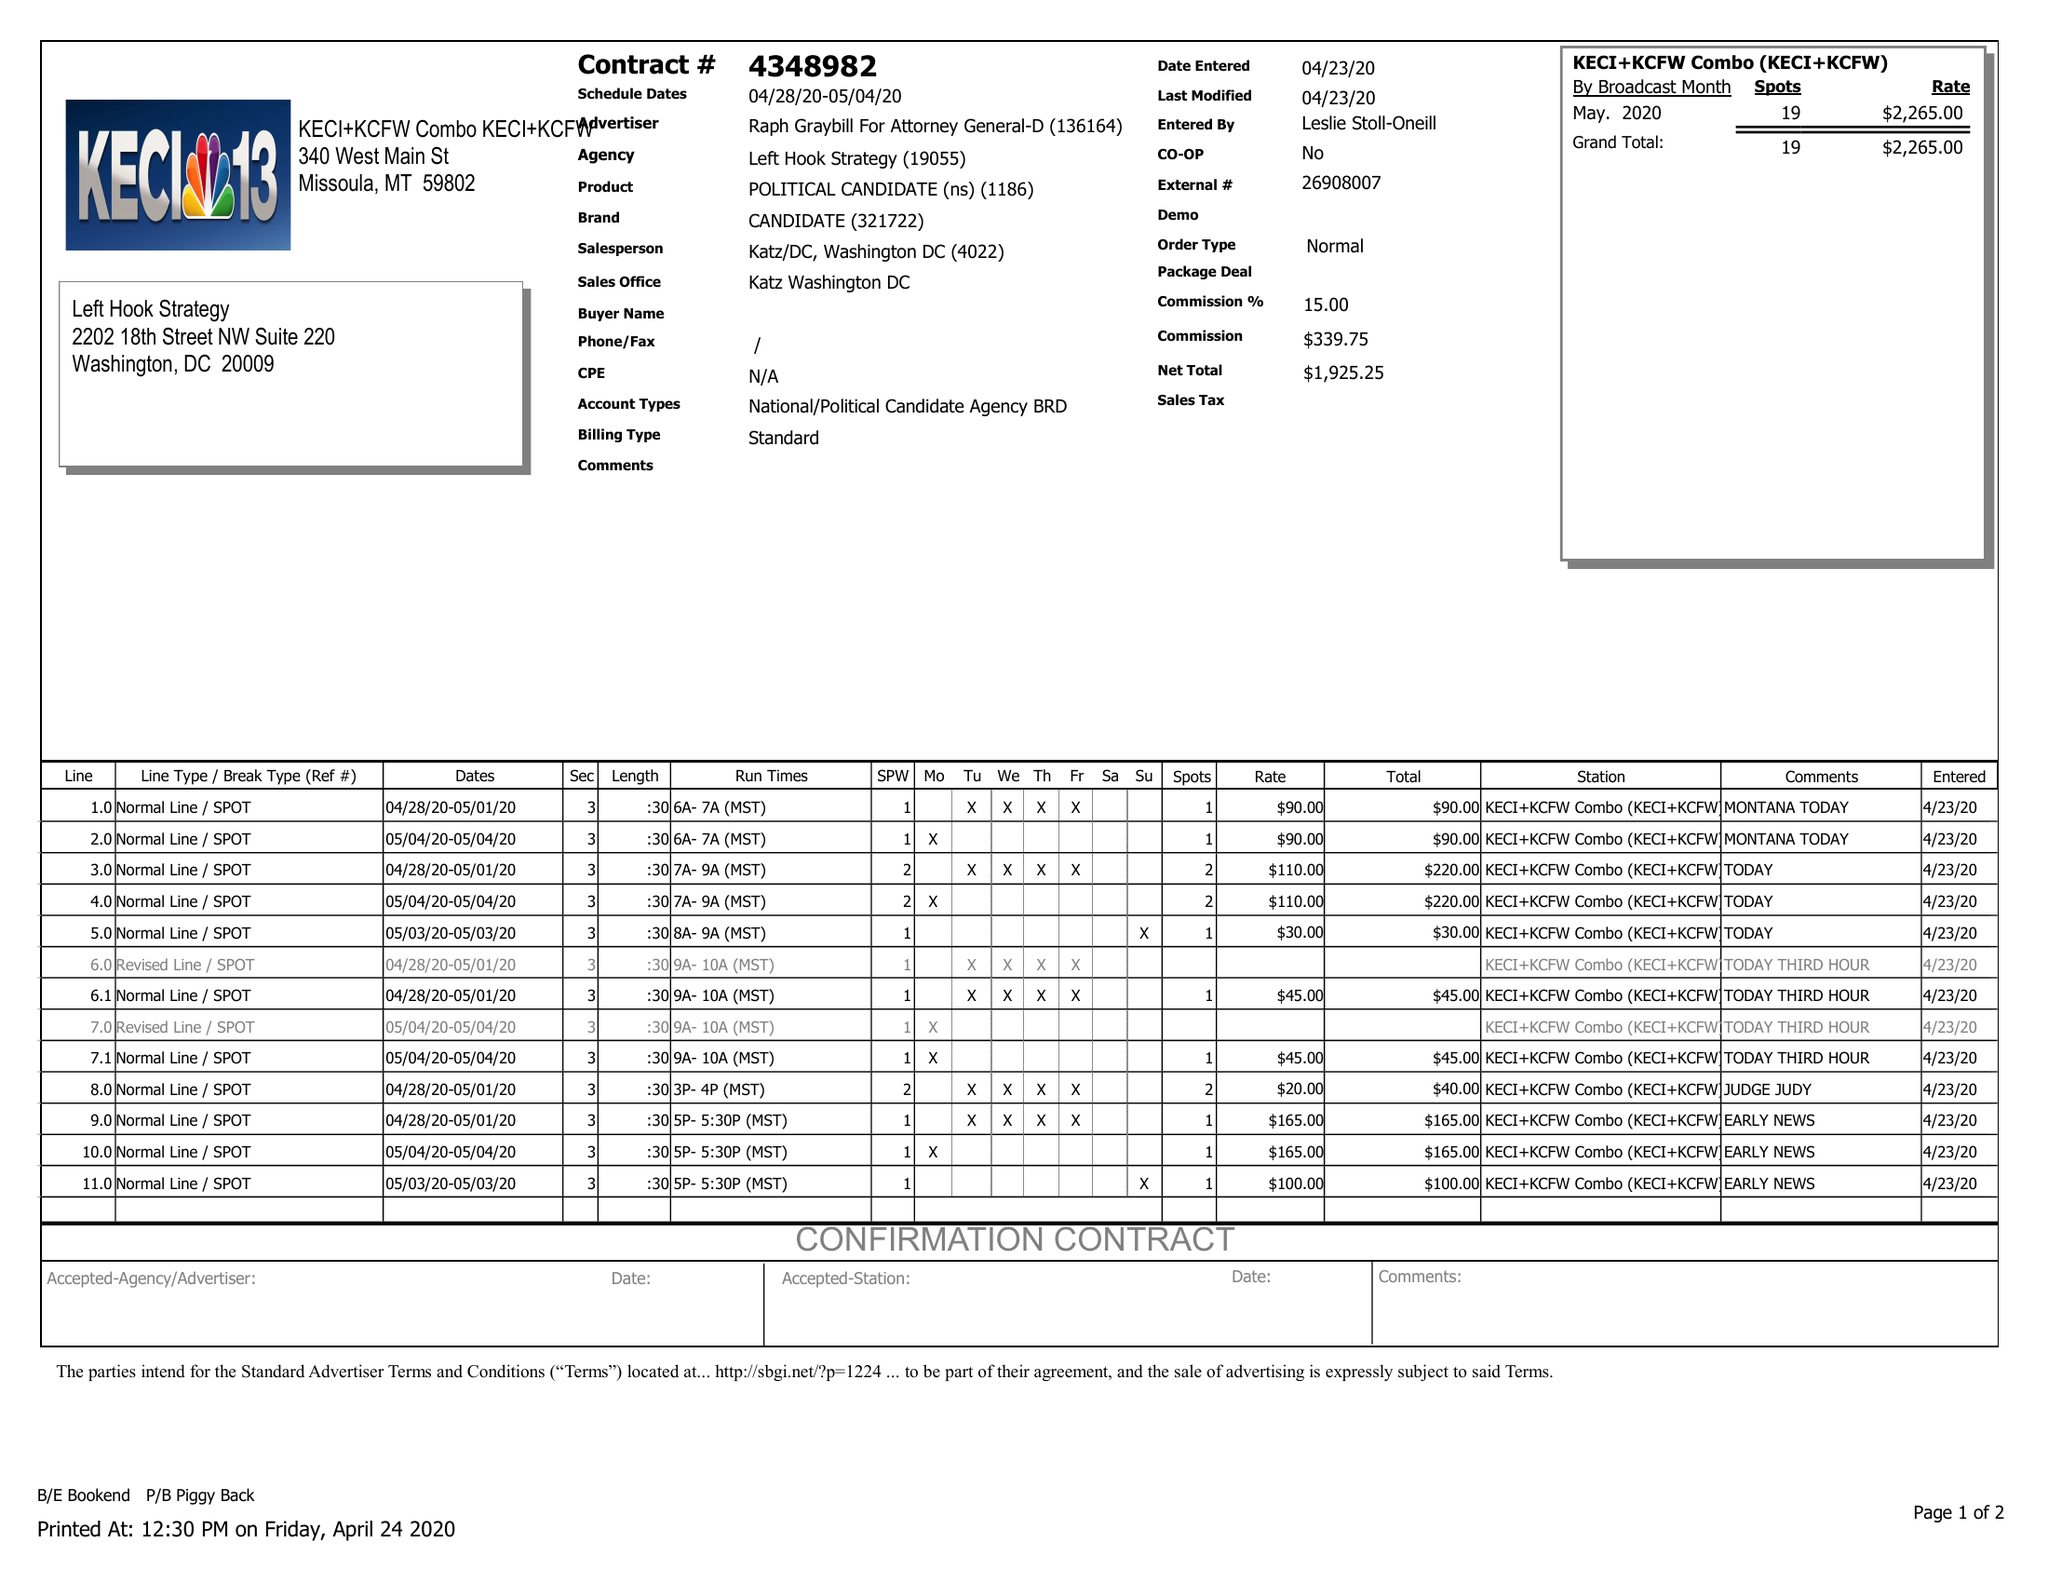What is the value for the gross_amount?
Answer the question using a single word or phrase. 2265.00 